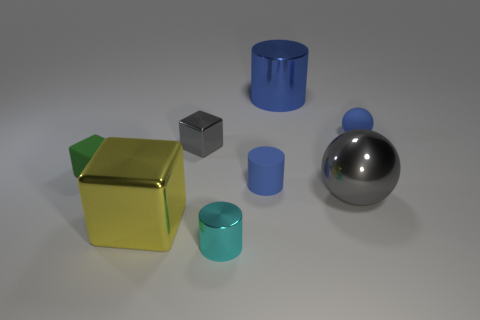There is a rubber cube that is the same size as the gray shiny cube; what color is it?
Offer a terse response. Green. What is the material of the gray ball?
Your answer should be compact. Metal. Are there any big yellow metallic blocks right of the yellow thing?
Make the answer very short. No. Does the blue shiny object have the same shape as the big yellow object?
Your answer should be very brief. No. What number of other things are there of the same size as the gray metal sphere?
Give a very brief answer. 2. What number of things are small objects that are on the right side of the cyan cylinder or large yellow objects?
Your response must be concise. 3. What color is the tiny matte cylinder?
Provide a short and direct response. Blue. There is a small green thing in front of the small metallic block; what is its material?
Provide a succinct answer. Rubber. Does the blue shiny object have the same shape as the blue object left of the big blue cylinder?
Your answer should be compact. Yes. Is the number of gray shiny blocks greater than the number of large things?
Your answer should be compact. No. 